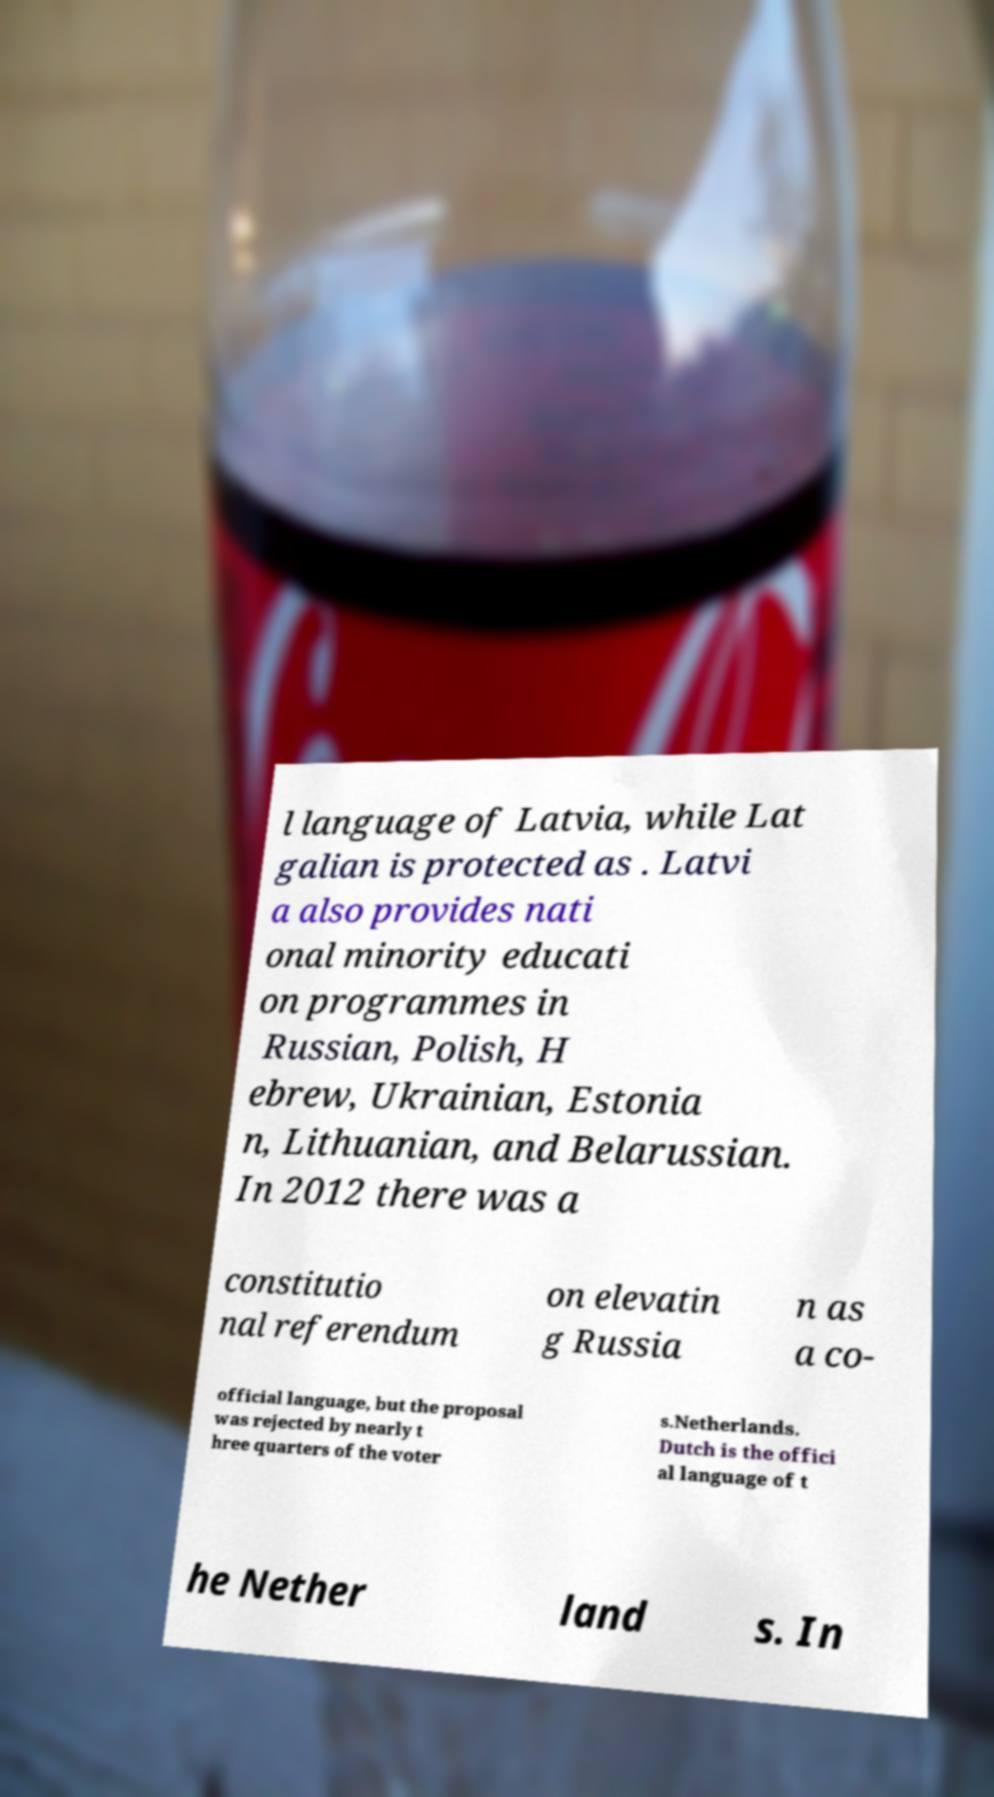For documentation purposes, I need the text within this image transcribed. Could you provide that? l language of Latvia, while Lat galian is protected as . Latvi a also provides nati onal minority educati on programmes in Russian, Polish, H ebrew, Ukrainian, Estonia n, Lithuanian, and Belarussian. In 2012 there was a constitutio nal referendum on elevatin g Russia n as a co- official language, but the proposal was rejected by nearly t hree quarters of the voter s.Netherlands. Dutch is the offici al language of t he Nether land s. In 